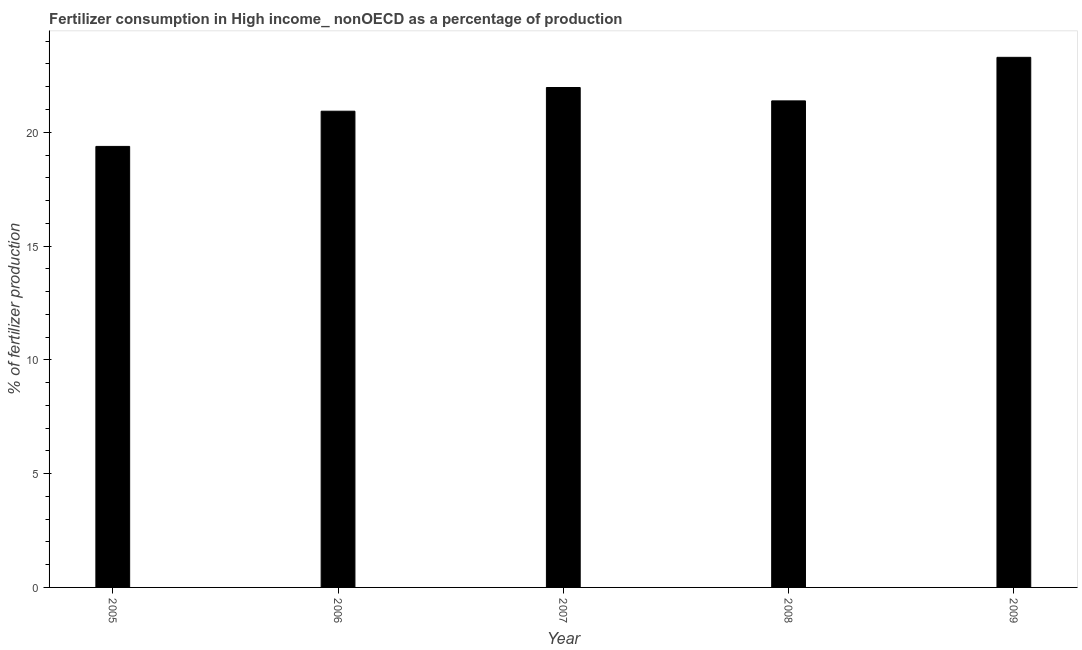Does the graph contain grids?
Give a very brief answer. No. What is the title of the graph?
Keep it short and to the point. Fertilizer consumption in High income_ nonOECD as a percentage of production. What is the label or title of the Y-axis?
Your response must be concise. % of fertilizer production. What is the amount of fertilizer consumption in 2005?
Provide a succinct answer. 19.38. Across all years, what is the maximum amount of fertilizer consumption?
Give a very brief answer. 23.29. Across all years, what is the minimum amount of fertilizer consumption?
Offer a terse response. 19.38. What is the sum of the amount of fertilizer consumption?
Make the answer very short. 106.94. What is the difference between the amount of fertilizer consumption in 2005 and 2007?
Offer a very short reply. -2.59. What is the average amount of fertilizer consumption per year?
Provide a short and direct response. 21.39. What is the median amount of fertilizer consumption?
Offer a very short reply. 21.38. In how many years, is the amount of fertilizer consumption greater than 6 %?
Give a very brief answer. 5. What is the ratio of the amount of fertilizer consumption in 2005 to that in 2007?
Make the answer very short. 0.88. Is the amount of fertilizer consumption in 2006 less than that in 2009?
Make the answer very short. Yes. Is the difference between the amount of fertilizer consumption in 2005 and 2009 greater than the difference between any two years?
Give a very brief answer. Yes. What is the difference between the highest and the second highest amount of fertilizer consumption?
Keep it short and to the point. 1.33. What is the difference between the highest and the lowest amount of fertilizer consumption?
Ensure brevity in your answer.  3.91. Are all the bars in the graph horizontal?
Make the answer very short. No. What is the difference between two consecutive major ticks on the Y-axis?
Give a very brief answer. 5. What is the % of fertilizer production of 2005?
Make the answer very short. 19.38. What is the % of fertilizer production of 2006?
Offer a terse response. 20.93. What is the % of fertilizer production in 2007?
Your answer should be very brief. 21.97. What is the % of fertilizer production of 2008?
Make the answer very short. 21.38. What is the % of fertilizer production in 2009?
Give a very brief answer. 23.29. What is the difference between the % of fertilizer production in 2005 and 2006?
Give a very brief answer. -1.55. What is the difference between the % of fertilizer production in 2005 and 2007?
Give a very brief answer. -2.59. What is the difference between the % of fertilizer production in 2005 and 2008?
Offer a terse response. -2. What is the difference between the % of fertilizer production in 2005 and 2009?
Provide a succinct answer. -3.91. What is the difference between the % of fertilizer production in 2006 and 2007?
Keep it short and to the point. -1.04. What is the difference between the % of fertilizer production in 2006 and 2008?
Offer a very short reply. -0.45. What is the difference between the % of fertilizer production in 2006 and 2009?
Offer a terse response. -2.37. What is the difference between the % of fertilizer production in 2007 and 2008?
Your answer should be compact. 0.59. What is the difference between the % of fertilizer production in 2007 and 2009?
Your answer should be very brief. -1.33. What is the difference between the % of fertilizer production in 2008 and 2009?
Make the answer very short. -1.91. What is the ratio of the % of fertilizer production in 2005 to that in 2006?
Your answer should be compact. 0.93. What is the ratio of the % of fertilizer production in 2005 to that in 2007?
Offer a terse response. 0.88. What is the ratio of the % of fertilizer production in 2005 to that in 2008?
Your answer should be very brief. 0.91. What is the ratio of the % of fertilizer production in 2005 to that in 2009?
Give a very brief answer. 0.83. What is the ratio of the % of fertilizer production in 2006 to that in 2007?
Ensure brevity in your answer.  0.95. What is the ratio of the % of fertilizer production in 2006 to that in 2008?
Provide a short and direct response. 0.98. What is the ratio of the % of fertilizer production in 2006 to that in 2009?
Your answer should be compact. 0.9. What is the ratio of the % of fertilizer production in 2007 to that in 2008?
Provide a short and direct response. 1.03. What is the ratio of the % of fertilizer production in 2007 to that in 2009?
Provide a succinct answer. 0.94. What is the ratio of the % of fertilizer production in 2008 to that in 2009?
Your response must be concise. 0.92. 